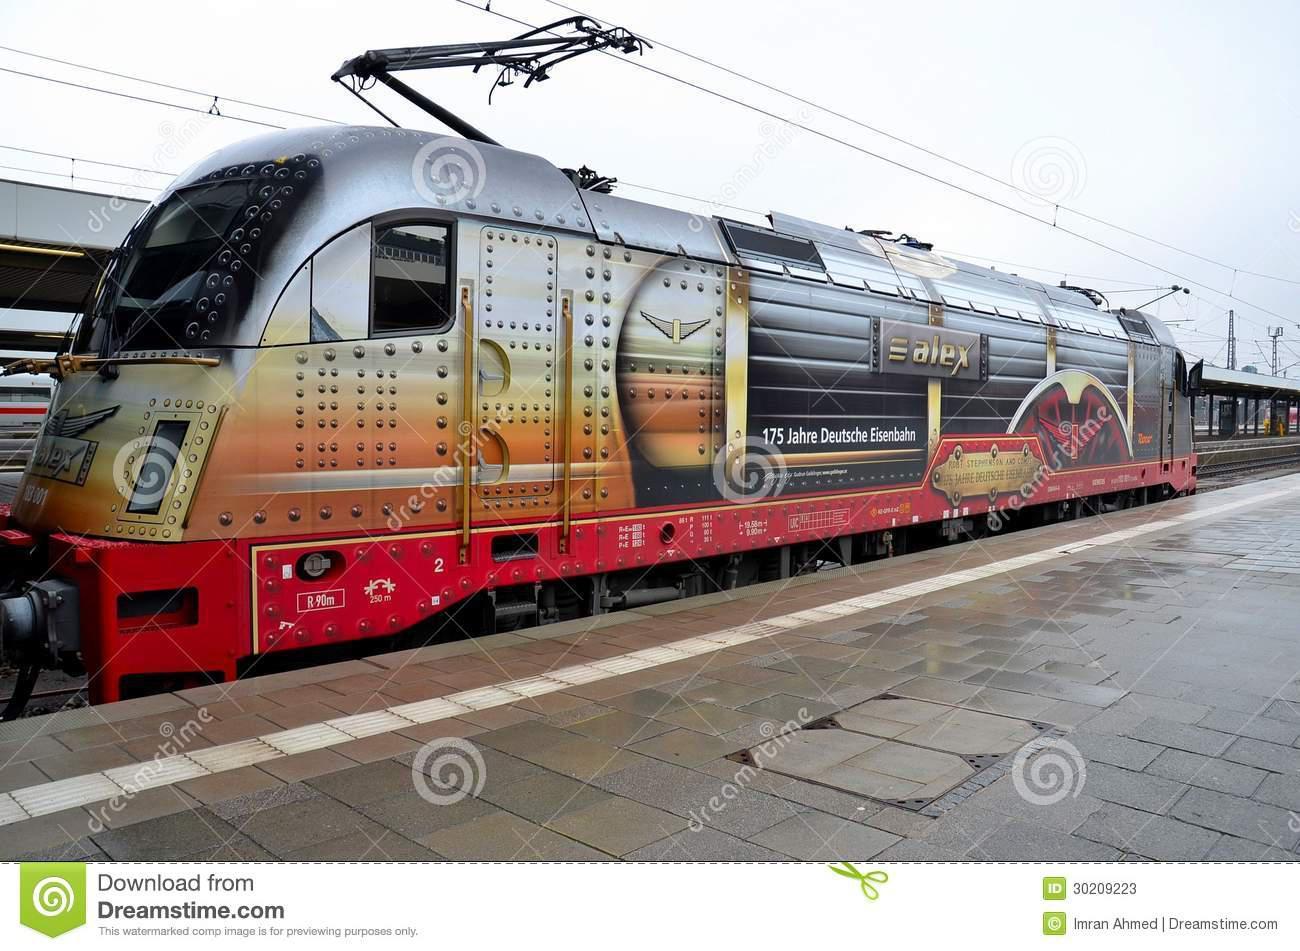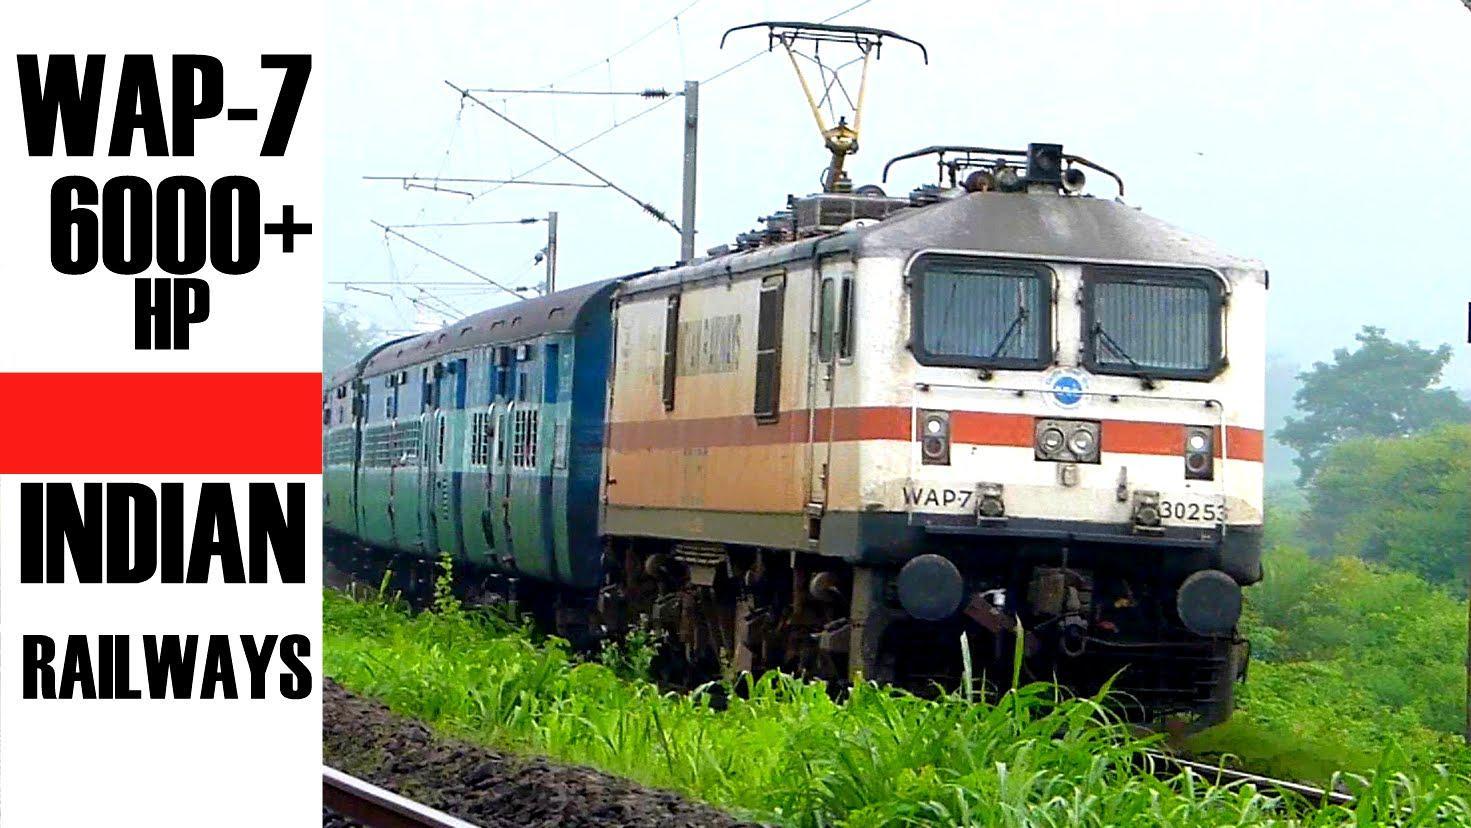The first image is the image on the left, the second image is the image on the right. Considering the images on both sides, is "There are three red stripes on the front of the train in the image on the left." valid? Answer yes or no. No. 